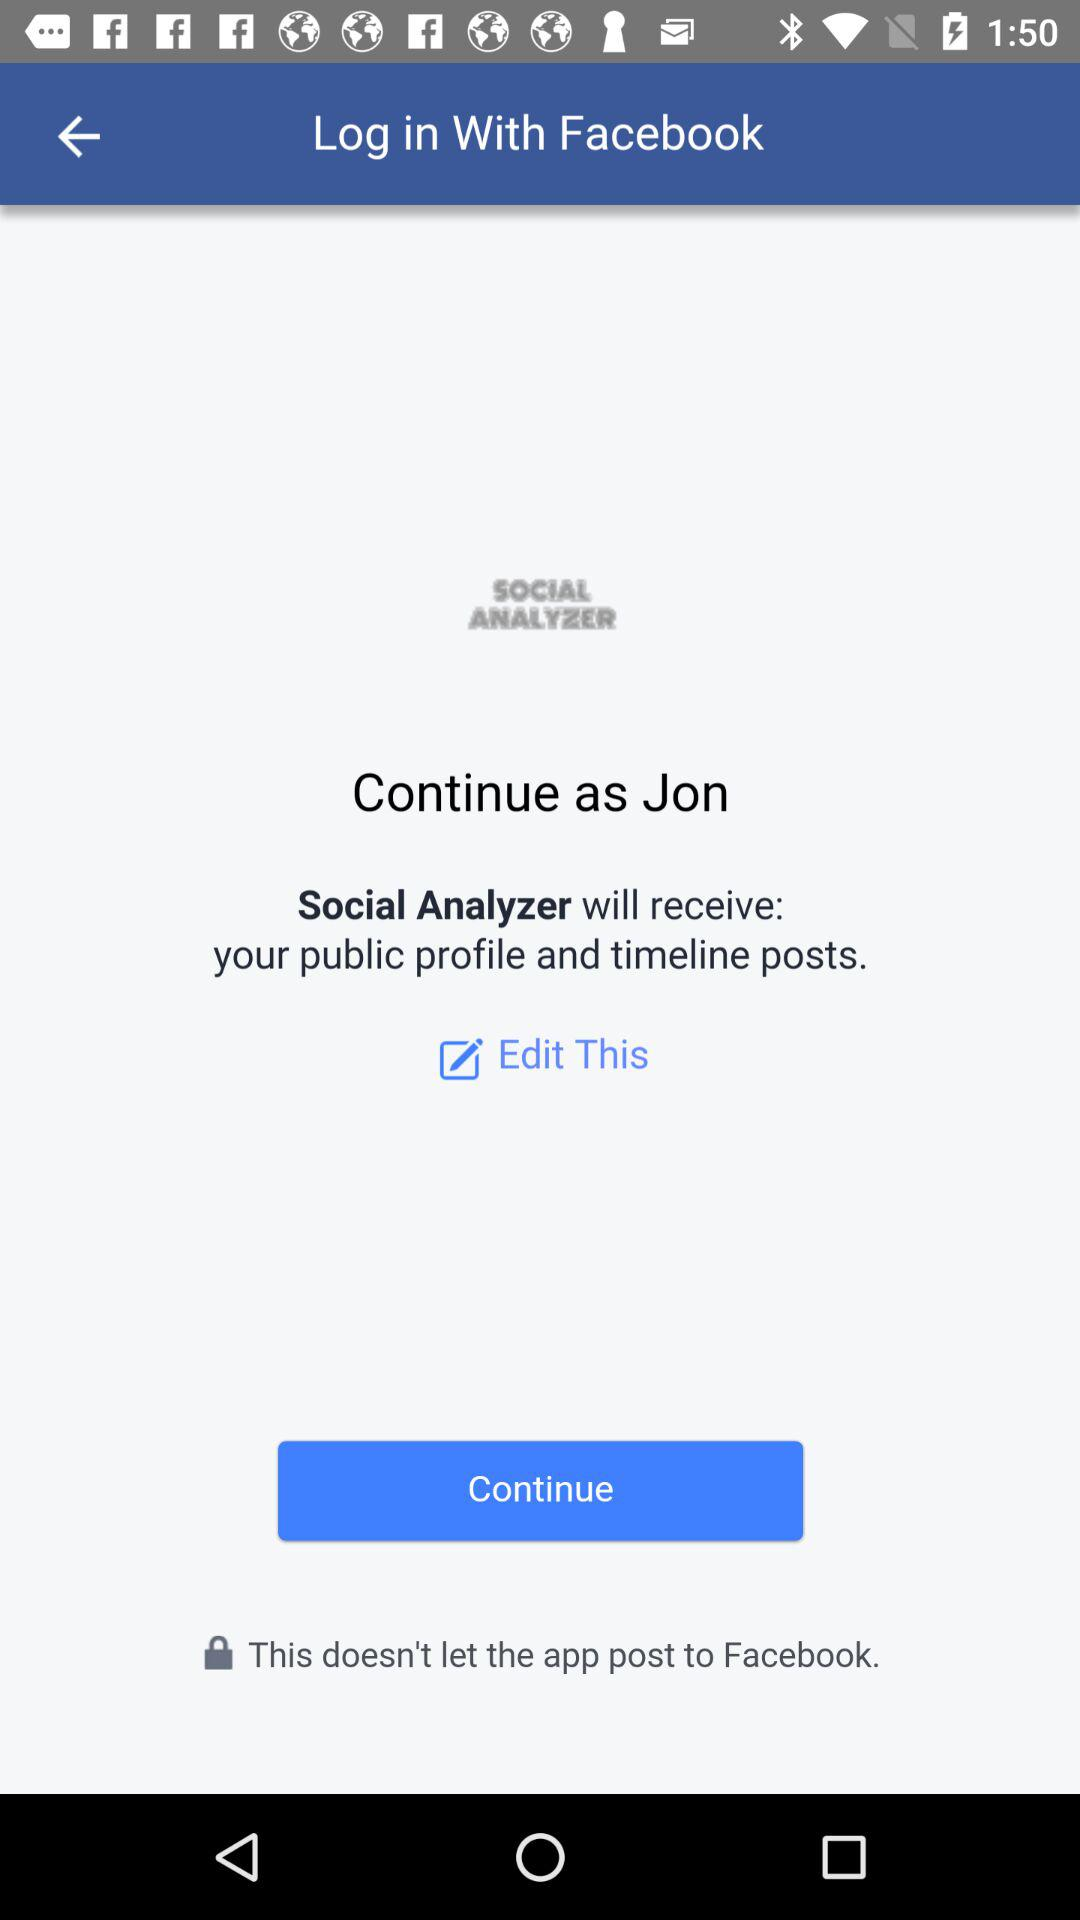What application is asking for permission? The application asking for permission is "Social Analyzer". 